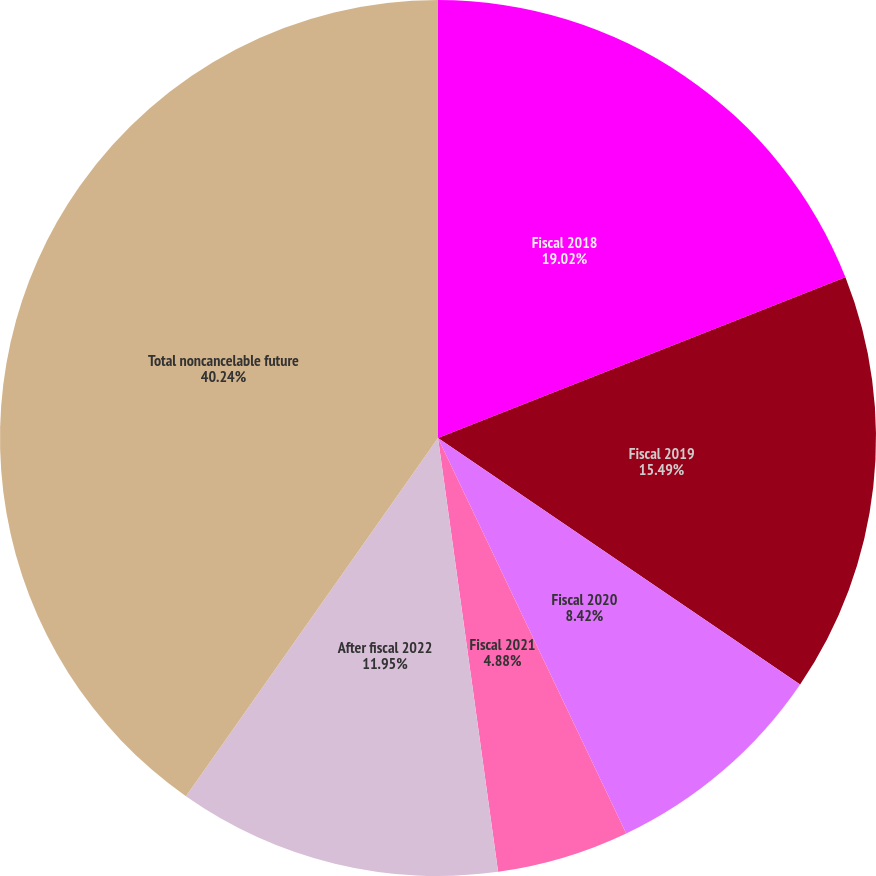<chart> <loc_0><loc_0><loc_500><loc_500><pie_chart><fcel>Fiscal 2018<fcel>Fiscal 2019<fcel>Fiscal 2020<fcel>Fiscal 2021<fcel>After fiscal 2022<fcel>Total noncancelable future<nl><fcel>19.02%<fcel>15.49%<fcel>8.42%<fcel>4.88%<fcel>11.95%<fcel>40.24%<nl></chart> 